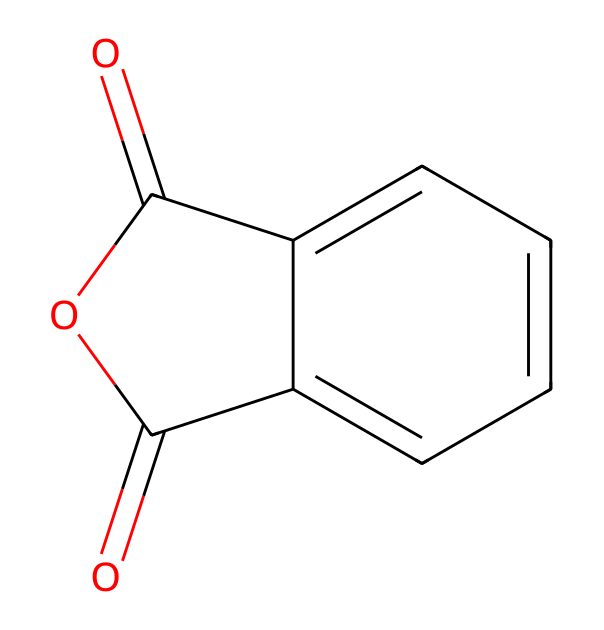What is the molecular formula of phthalic anhydride? To find the molecular formula, count the carbon (C), hydrogen (H), and oxygen (O) atoms in the structure. There are 8 carbon atoms, 4 hydrogen atoms, and 3 oxygen atoms, leading to the formula C8H4O3.
Answer: C8H4O3 How many rings are present in the structure of phthalic anhydride? The SMILES representation shows one cyclic structure indicated by 'C1' and 'C2', which suggests there is one ring in the molecule.
Answer: one What type of chemical bonds are present in phthalic anhydride? By examining the structure, it can be seen that there are double bonds (C=O and C=C) and single bonds (C-C, C-O) in the molecule.
Answer: double and single bonds What functional groups are found in phthalic anhydride? Analyzing the structure, phthalic anhydride contains carboxylic anhydride groups (the 'O=C1OC=O' part signifies this), which are characteristic of anhydrides.
Answer: carboxylic anhydride Why is phthalic anhydride classified as an acid anhydride? An acid anhydride is formed from the removal of water from two carboxylic acids. Phthalic anhydride has two carbonyl groups connected to a cyclic structure which fits this definition.
Answer: due to its structure containing carbonyl groups How does the molecular structure of phthalic anhydride relate to its use in performing arts? The structure includes anhydride functional groups, which contribute to its reactivity and utility as a plasticizer in materials, making it suitable for stage makeup and costumes.
Answer: it acts as a plasticizer 